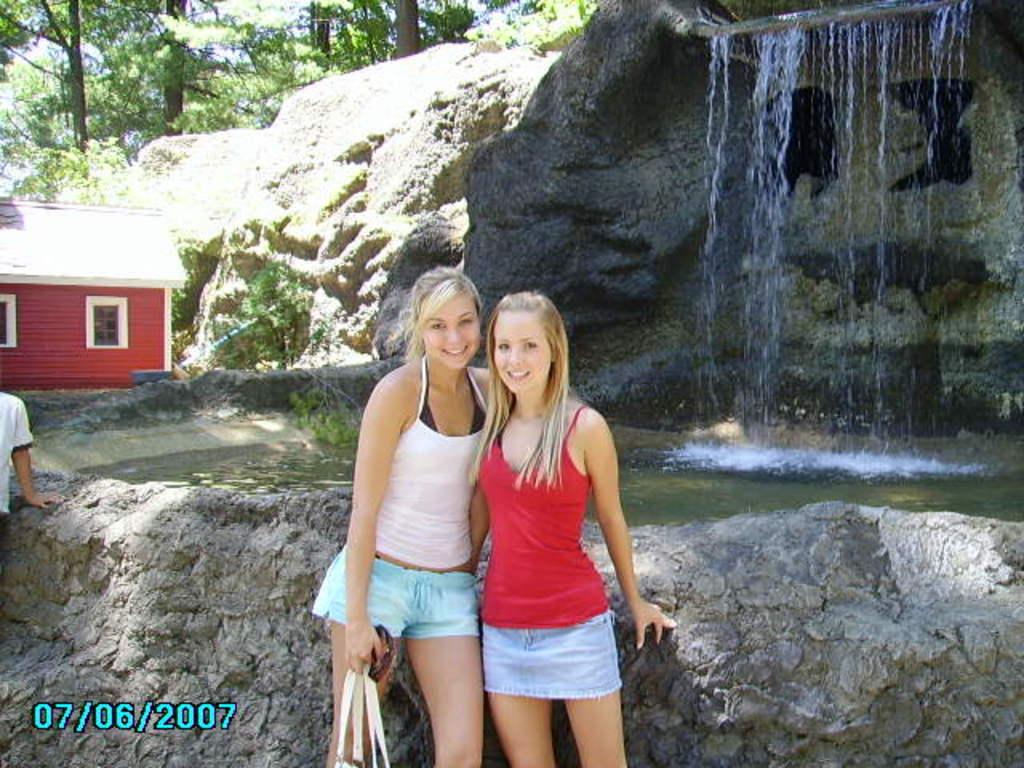What date was the photo taken?
Provide a succinct answer. 07/06/2007. What is the date that the photo was taken?
Your answer should be very brief. 07/06/2007. 